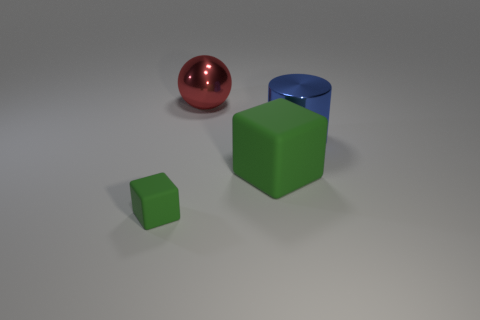Add 1 brown things. How many objects exist? 5 Subtract 0 gray balls. How many objects are left? 4 Subtract all cylinders. How many objects are left? 3 Subtract 1 blocks. How many blocks are left? 1 Subtract all cyan blocks. Subtract all cyan balls. How many blocks are left? 2 Subtract all tiny purple matte blocks. Subtract all large red balls. How many objects are left? 3 Add 1 red metal balls. How many red metal balls are left? 2 Add 2 large green metal balls. How many large green metal balls exist? 2 